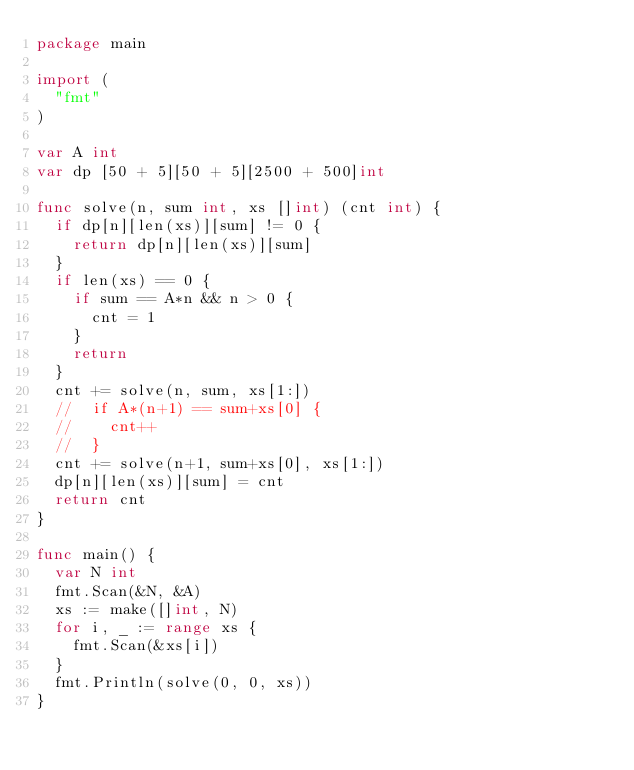Convert code to text. <code><loc_0><loc_0><loc_500><loc_500><_Go_>package main

import (
	"fmt"
)

var A int
var dp [50 + 5][50 + 5][2500 + 500]int

func solve(n, sum int, xs []int) (cnt int) {
	if dp[n][len(xs)][sum] != 0 {
		return dp[n][len(xs)][sum]
	}
	if len(xs) == 0 {
		if sum == A*n && n > 0 {
			cnt = 1
		}
		return
	}
	cnt += solve(n, sum, xs[1:])
	//	if A*(n+1) == sum+xs[0] {
	//		cnt++
	//	}
	cnt += solve(n+1, sum+xs[0], xs[1:])
	dp[n][len(xs)][sum] = cnt
	return cnt
}

func main() {
	var N int
	fmt.Scan(&N, &A)
	xs := make([]int, N)
	for i, _ := range xs {
		fmt.Scan(&xs[i])
	}
	fmt.Println(solve(0, 0, xs))
}
</code> 